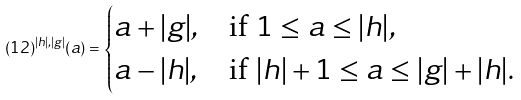<formula> <loc_0><loc_0><loc_500><loc_500>( 1 2 ) ^ { | h | , | g | } ( a ) = \begin{cases} a + | g | , & \text {if $1 \leq a \leq |h|$} , \\ a - | h | , & \text {if $|h|+1 \leq a \leq |g|+|h|$} . \end{cases}</formula> 